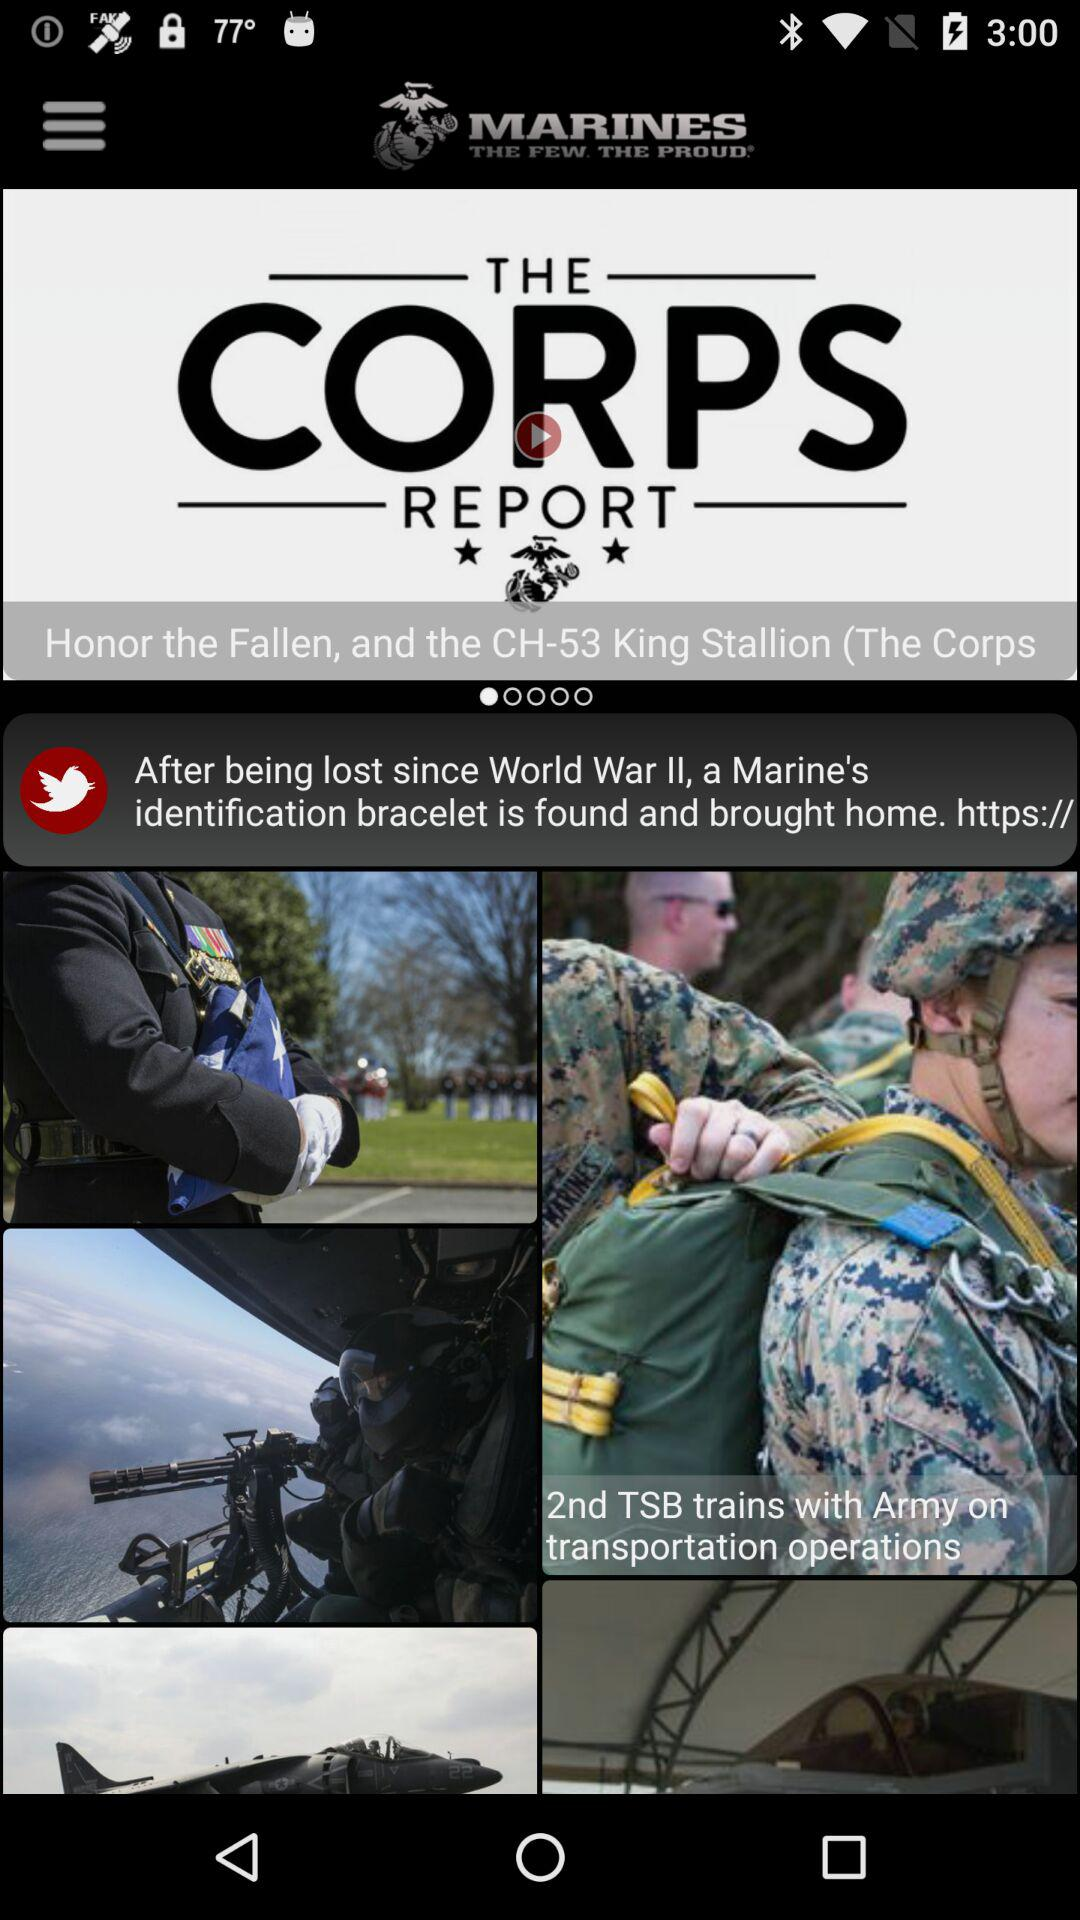What is the application name?
When the provided information is insufficient, respond with <no answer>. <no answer> 